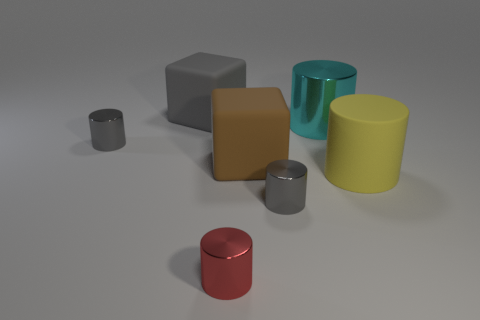What could these cylinders represent in a more abstract or symbolic representation? In an abstract sense, these cylinders could represent the diverse range of human personalities or traits. The varying colors and textures might symbolize the unique characteristics that distinguish individuals - the matte surface akin to a more reserved nature, while the reflective surface might imply an outgoing and vibrant personality. 